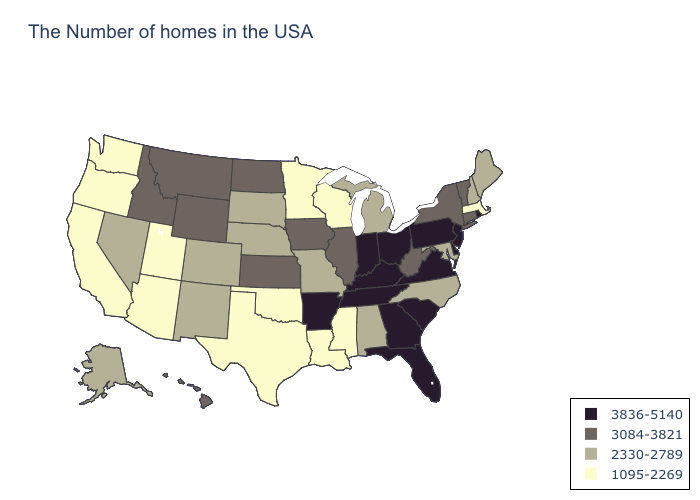Name the states that have a value in the range 3836-5140?
Give a very brief answer. Rhode Island, New Jersey, Delaware, Pennsylvania, Virginia, South Carolina, Ohio, Florida, Georgia, Kentucky, Indiana, Tennessee, Arkansas. What is the value of Rhode Island?
Keep it brief. 3836-5140. Which states have the highest value in the USA?
Give a very brief answer. Rhode Island, New Jersey, Delaware, Pennsylvania, Virginia, South Carolina, Ohio, Florida, Georgia, Kentucky, Indiana, Tennessee, Arkansas. What is the highest value in states that border Oklahoma?
Quick response, please. 3836-5140. Does Connecticut have the highest value in the Northeast?
Answer briefly. No. Which states have the highest value in the USA?
Concise answer only. Rhode Island, New Jersey, Delaware, Pennsylvania, Virginia, South Carolina, Ohio, Florida, Georgia, Kentucky, Indiana, Tennessee, Arkansas. Name the states that have a value in the range 3084-3821?
Answer briefly. Vermont, Connecticut, New York, West Virginia, Illinois, Iowa, Kansas, North Dakota, Wyoming, Montana, Idaho, Hawaii. Among the states that border Ohio , does West Virginia have the highest value?
Short answer required. No. Among the states that border Vermont , which have the lowest value?
Give a very brief answer. Massachusetts. Name the states that have a value in the range 3836-5140?
Write a very short answer. Rhode Island, New Jersey, Delaware, Pennsylvania, Virginia, South Carolina, Ohio, Florida, Georgia, Kentucky, Indiana, Tennessee, Arkansas. What is the value of Oklahoma?
Answer briefly. 1095-2269. Does New Hampshire have the highest value in the Northeast?
Write a very short answer. No. Does Texas have the lowest value in the USA?
Concise answer only. Yes. Is the legend a continuous bar?
Answer briefly. No. Does Kentucky have the highest value in the USA?
Write a very short answer. Yes. 